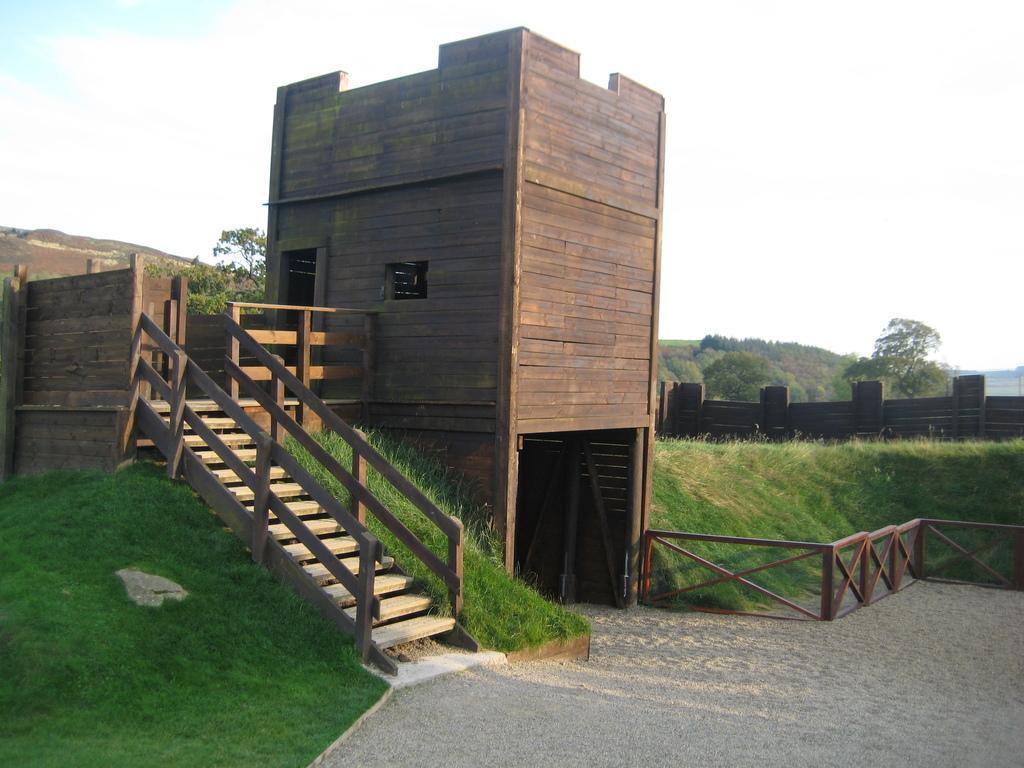Describe this image in one or two sentences. In this image I can see a staircase and building and grass visible in the middle , in the background I can see the sky and a fence visible in the middle. 